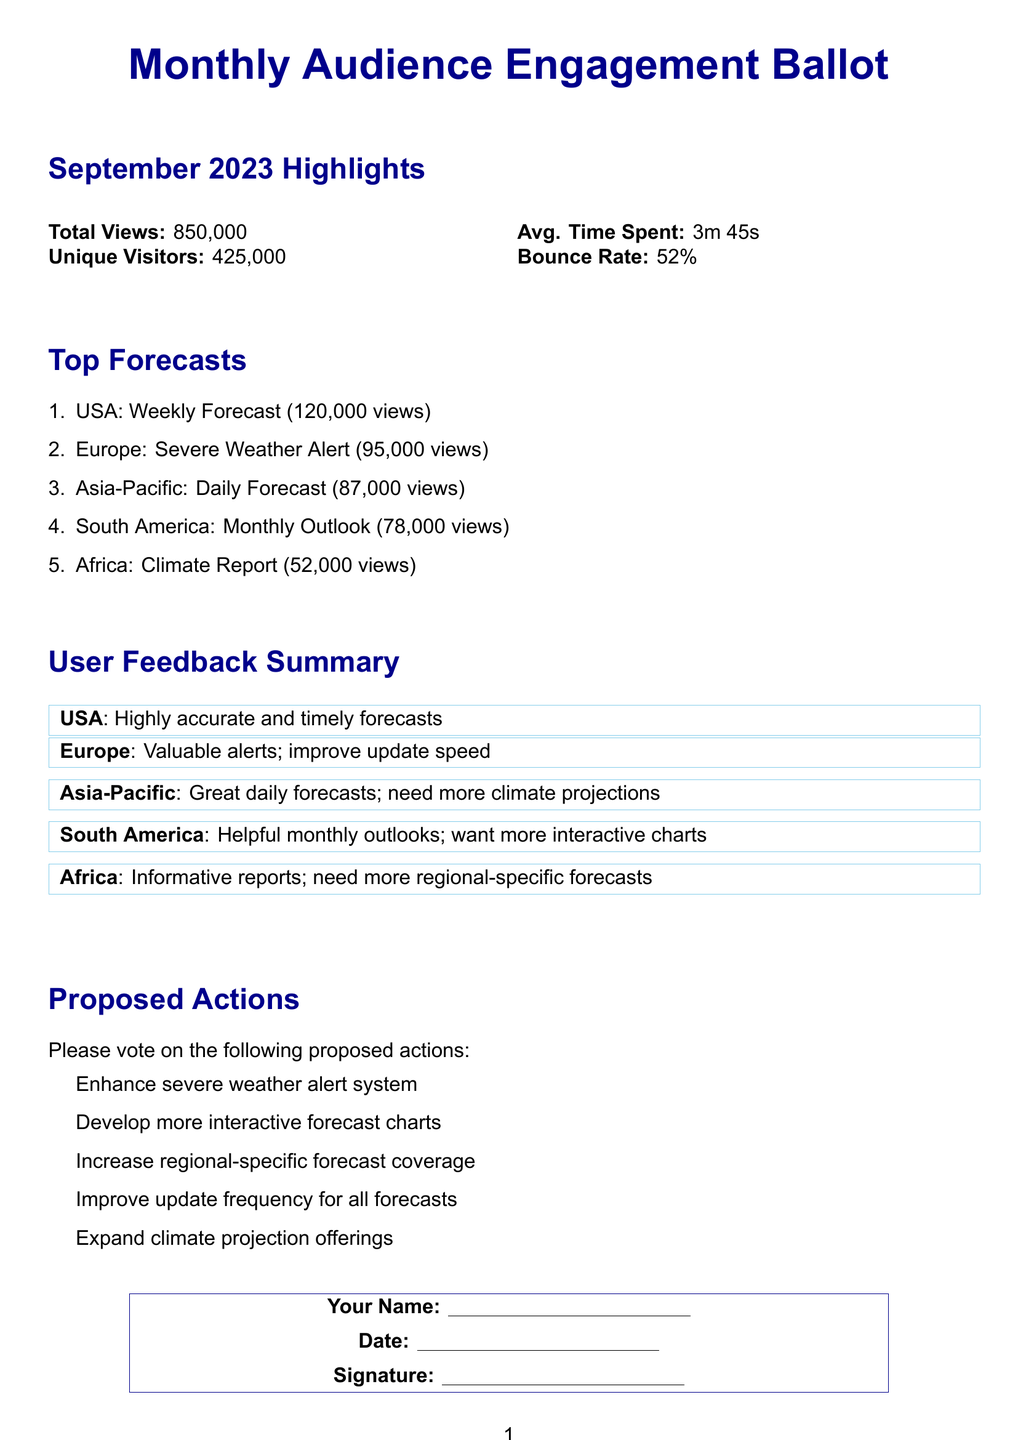What is the total views for September 2023? The total views are explicitly stated in the document as part of the highlights.
Answer: 850,000 How many unique visitors did the website have? The number of unique visitors is provided in the highlights section.
Answer: 425,000 What was the average time spent on the site? The average time spent is mentioned in the highlights.
Answer: 3m 45s Which forecast had the highest views? The highest viewed forecast is listed as the first item in the top forecasts section.
Answer: USA: Weekly Forecast What was the bounce rate for the month? The bounce rate is included in the highlights as a statistic.
Answer: 52% How many views did the Europe Severe Weather Alert receive? The views for Europe Severe Weather Alert are specified in the top forecasts.
Answer: 95,000 views What proposed action is related to interactive forecast tools? The proposed action regarding interactive forecast tools is found in the proposed actions section.
Answer: Develop more interactive forecast charts Which region needs more climate projections according to feedback? The feedback mentions a need for more climate projections specifically from one region.
Answer: Asia-Pacific What type of document is this? The structure and content clearly indicate the type of document it represents.
Answer: Ballot 